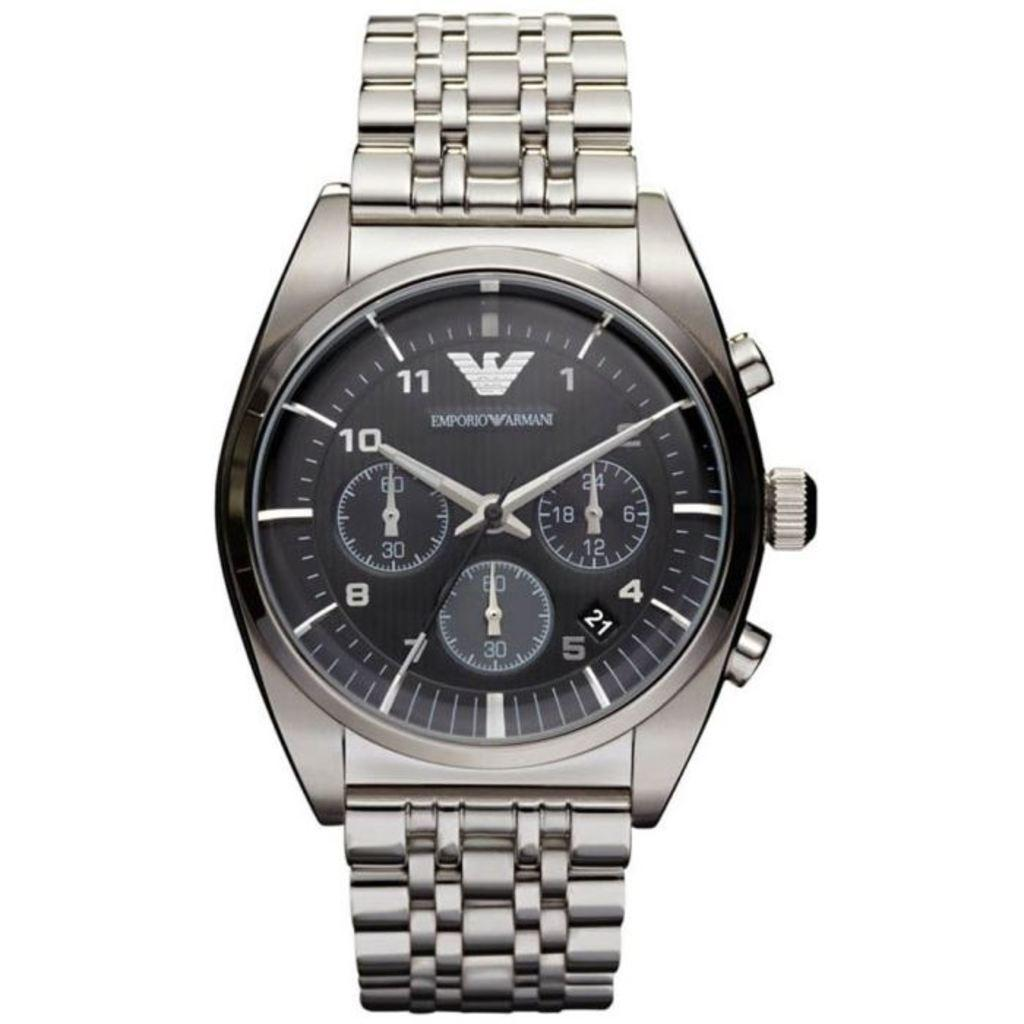Provide a one-sentence caption for the provided image. The silver and black watch is a Armani branded watch. 